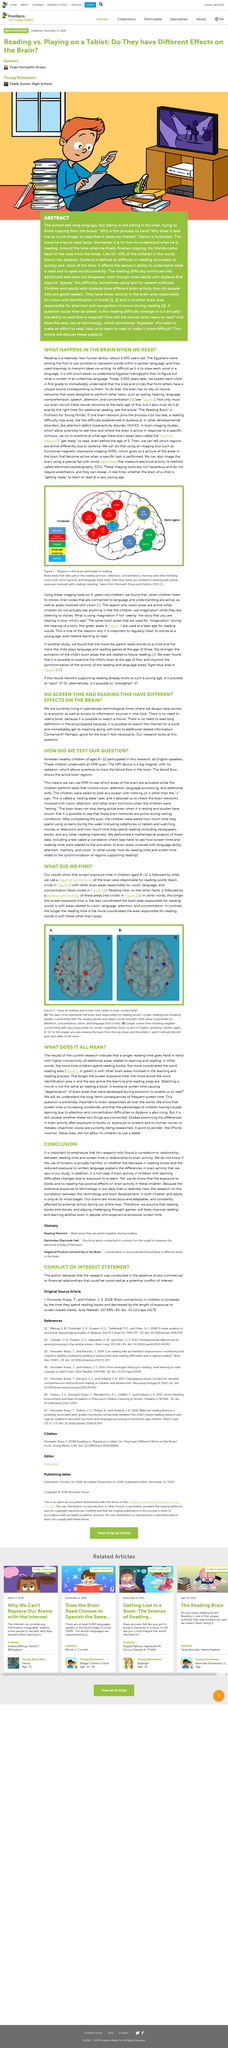Draw attention to some important aspects in this diagram. The caption implies that the picture shows a relationship between reading and screen time and brain connectivity. Functional magnetic resonance imaging, or fMRI, is a technique that uses magnetic fields and radio waves to produce detailed images of the brain's activity. The longer the reading time, the greater the connectivity with the reading words area indicates an increased level of connectivity between the two areas. The use of an fMRI scan was employed to scan the children. Green represents the regions of the brain engaged in vision in the figure. 